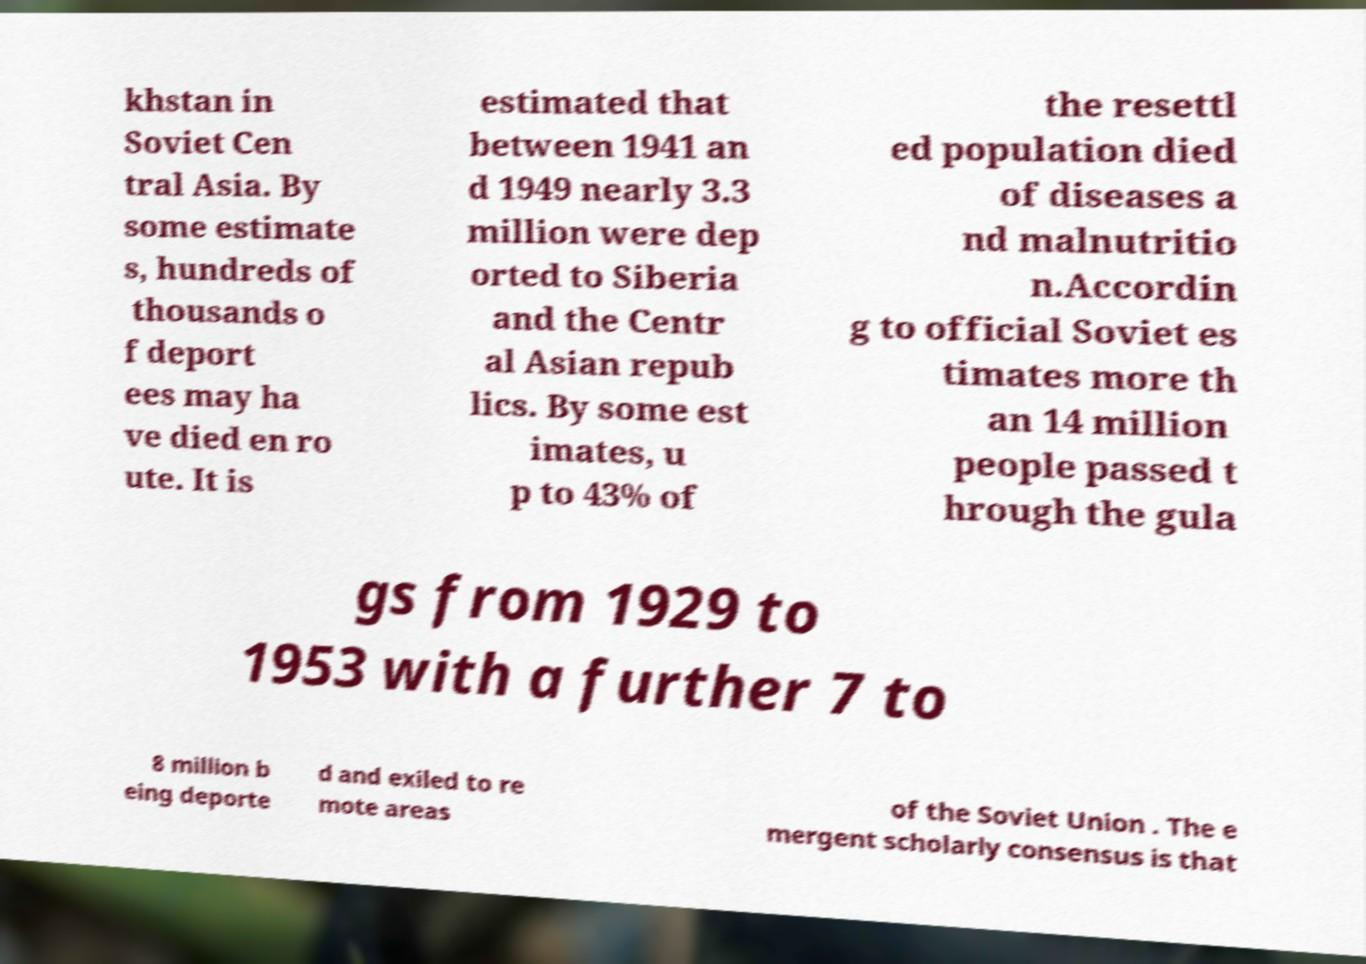Please read and relay the text visible in this image. What does it say? khstan in Soviet Cen tral Asia. By some estimate s, hundreds of thousands o f deport ees may ha ve died en ro ute. It is estimated that between 1941 an d 1949 nearly 3.3 million were dep orted to Siberia and the Centr al Asian repub lics. By some est imates, u p to 43% of the resettl ed population died of diseases a nd malnutritio n.Accordin g to official Soviet es timates more th an 14 million people passed t hrough the gula gs from 1929 to 1953 with a further 7 to 8 million b eing deporte d and exiled to re mote areas of the Soviet Union . The e mergent scholarly consensus is that 